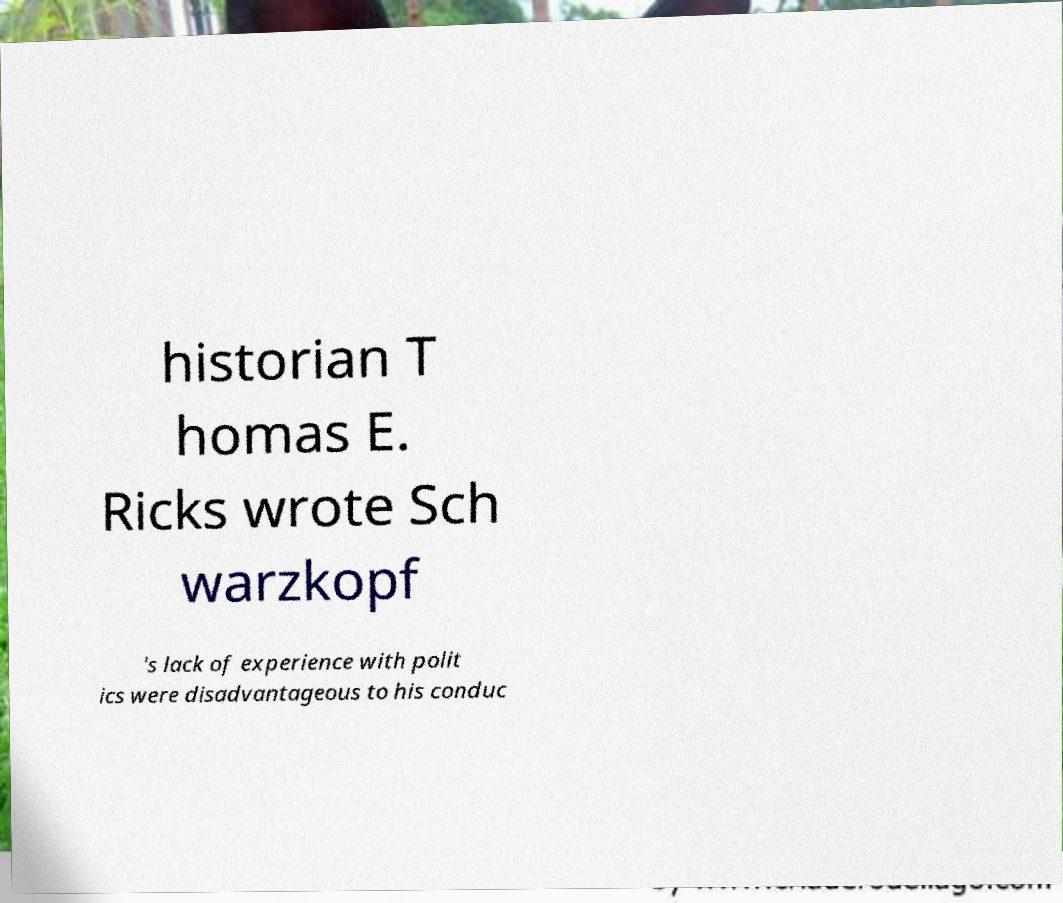There's text embedded in this image that I need extracted. Can you transcribe it verbatim? historian T homas E. Ricks wrote Sch warzkopf 's lack of experience with polit ics were disadvantageous to his conduc 